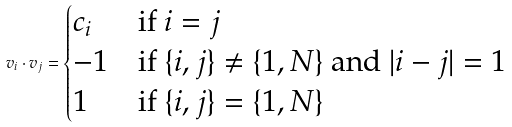Convert formula to latex. <formula><loc_0><loc_0><loc_500><loc_500>v _ { i } \cdot v _ { j } = \begin{cases} c _ { i } & \text {if $i=j$} \\ - 1 & \text {if $\{i,j\}\neq\{1,N\}$ and $|i-j|=1$} \\ 1 & \text {if $\{i,j\}=\{1,N\}$} \end{cases}</formula> 